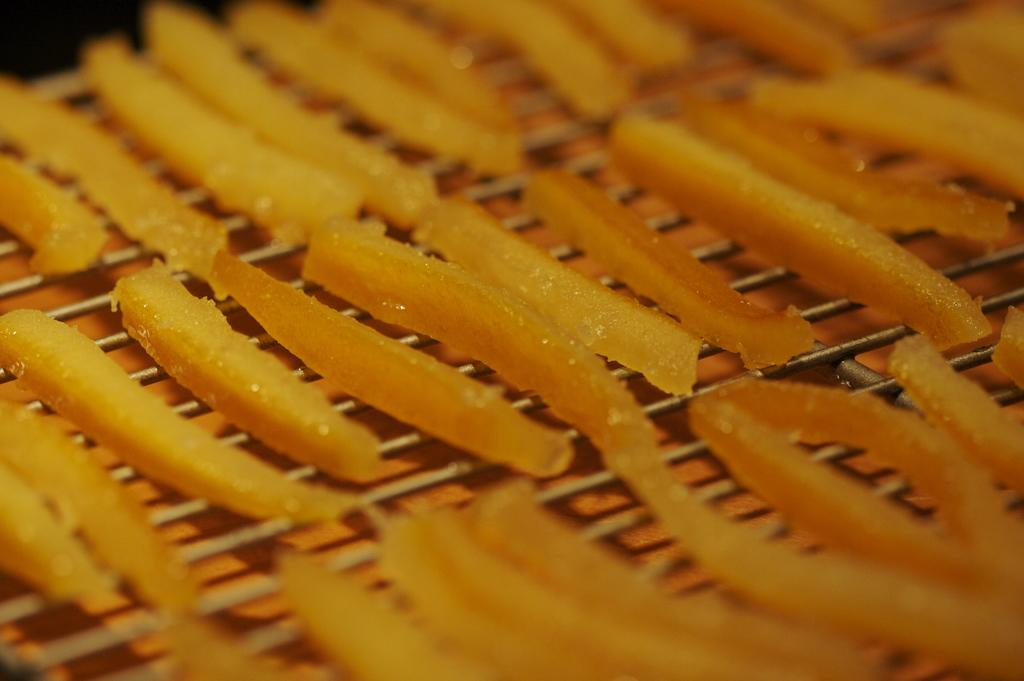What is present in the image? There are food items in the image. How are the food items arranged in the image? The food items are arranged on a grille. Can you see a maid holding a drum while an owl watches nearby in the image? No, there is no maid, drum, or owl present in the image. The image only contains food items arranged on a grille. 